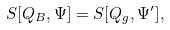<formula> <loc_0><loc_0><loc_500><loc_500>S [ Q _ { B } , \Psi ] = S [ Q _ { g } , \Psi ^ { \prime } ] ,</formula> 